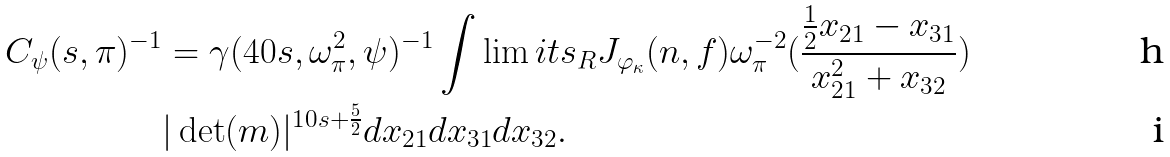<formula> <loc_0><loc_0><loc_500><loc_500>C _ { \psi } ( s , \pi ) ^ { - 1 } & = \gamma ( 4 0 s , \omega _ { \pi } ^ { 2 } , \psi ) ^ { - 1 } \int \lim i t s _ { R } J _ { \varphi _ { \kappa } } ( n , f ) \omega _ { \pi } ^ { - 2 } ( \frac { \frac { 1 } { 2 } x _ { 2 1 } - x _ { 3 1 } } { x _ { 2 1 } ^ { 2 } + x _ { 3 2 } } ) \\ & | \det ( m ) | ^ { 1 0 s + \frac { 5 } { 2 } } d x _ { 2 1 } d x _ { 3 1 } d x _ { 3 2 } .</formula> 